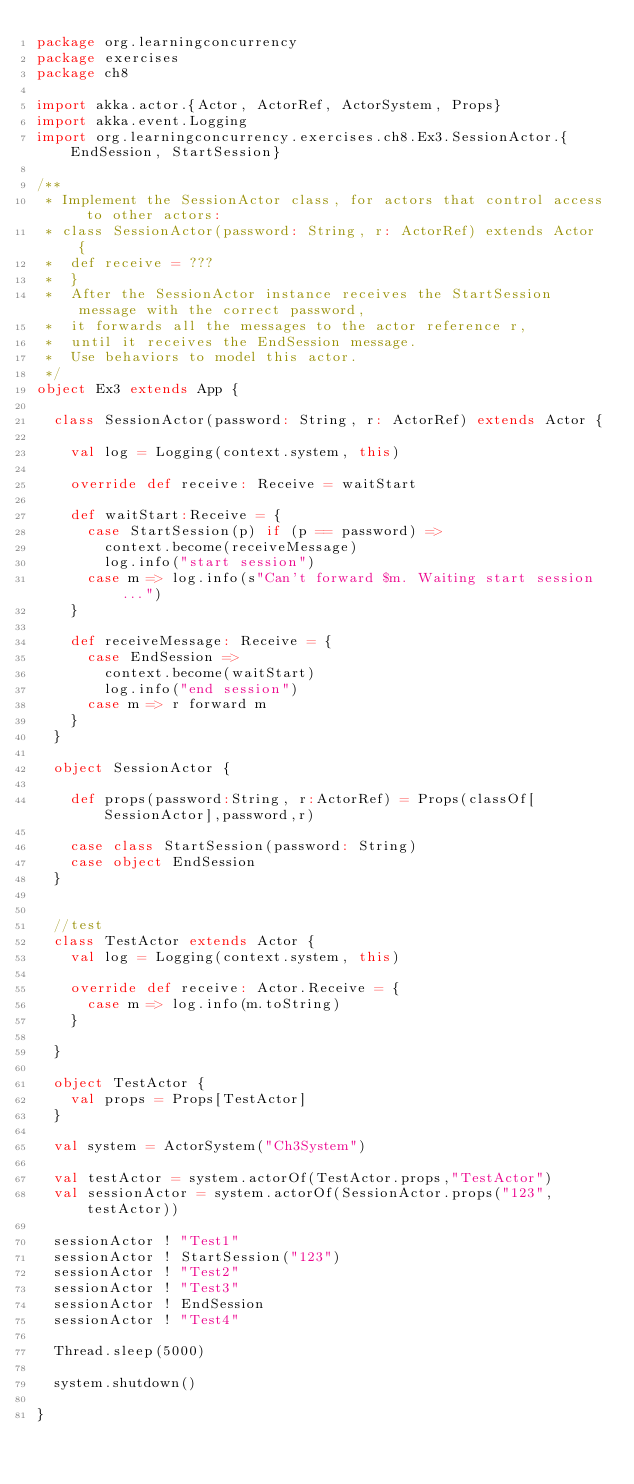<code> <loc_0><loc_0><loc_500><loc_500><_Scala_>package org.learningconcurrency
package exercises
package ch8

import akka.actor.{Actor, ActorRef, ActorSystem, Props}
import akka.event.Logging
import org.learningconcurrency.exercises.ch8.Ex3.SessionActor.{EndSession, StartSession}

/**
 * Implement the SessionActor class, for actors that control access to other actors:
 * class SessionActor(password: String, r: ActorRef) extends Actor {
 *  def receive = ???
 *  }
 *  After the SessionActor instance receives the StartSession message with the correct password,
 *  it forwards all the messages to the actor reference r,
 *  until it receives the EndSession message.
 *  Use behaviors to model this actor.
 */
object Ex3 extends App {

  class SessionActor(password: String, r: ActorRef) extends Actor {

    val log = Logging(context.system, this)

    override def receive: Receive = waitStart

    def waitStart:Receive = {
      case StartSession(p) if (p == password) =>
        context.become(receiveMessage)
        log.info("start session")
      case m => log.info(s"Can't forward $m. Waiting start session ...")
    }

    def receiveMessage: Receive = {
      case EndSession =>
        context.become(waitStart)
        log.info("end session")
      case m => r forward m
    }
  }

  object SessionActor {

    def props(password:String, r:ActorRef) = Props(classOf[SessionActor],password,r)

    case class StartSession(password: String)
    case object EndSession
  }


  //test
  class TestActor extends Actor {
    val log = Logging(context.system, this)

    override def receive: Actor.Receive = {
      case m => log.info(m.toString)
    }

  }

  object TestActor {
    val props = Props[TestActor]
  }

  val system = ActorSystem("Ch3System")

  val testActor = system.actorOf(TestActor.props,"TestActor")
  val sessionActor = system.actorOf(SessionActor.props("123",testActor))

  sessionActor ! "Test1"
  sessionActor ! StartSession("123")
  sessionActor ! "Test2"
  sessionActor ! "Test3"
  sessionActor ! EndSession
  sessionActor ! "Test4"

  Thread.sleep(5000)

  system.shutdown()

}
</code> 